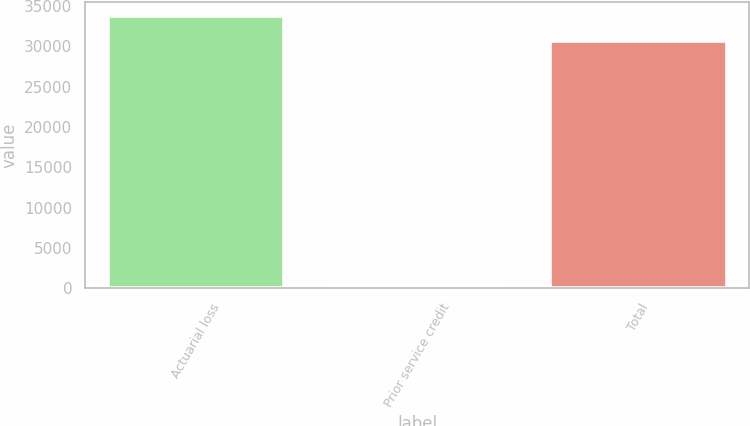Convert chart. <chart><loc_0><loc_0><loc_500><loc_500><bar_chart><fcel>Actuarial loss<fcel>Prior service credit<fcel>Total<nl><fcel>33787.6<fcel>430<fcel>30716<nl></chart> 